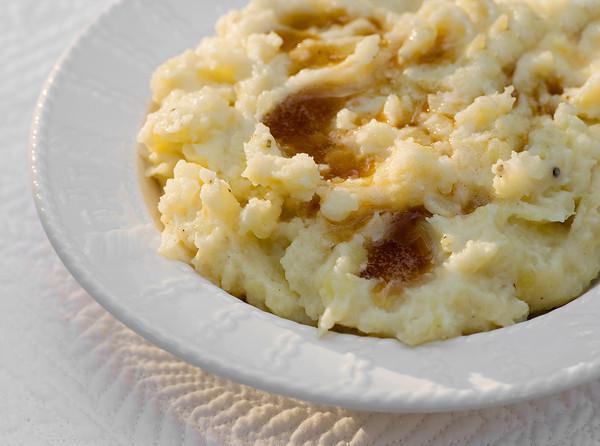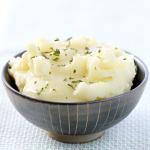The first image is the image on the left, the second image is the image on the right. Evaluate the accuracy of this statement regarding the images: "One of the dishes of potatoes has a utensil stuck into the food.". Is it true? Answer yes or no. No. The first image is the image on the left, the second image is the image on the right. Evaluate the accuracy of this statement regarding the images: "There is a white plate of mashed potatoes and gravy in the image on the left.". Is it true? Answer yes or no. Yes. 